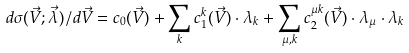<formula> <loc_0><loc_0><loc_500><loc_500>d \sigma ( \vec { V } ; \vec { \lambda } ) / d \vec { V } = c _ { 0 } ( \vec { V } ) + \sum _ { k } c ^ { k } _ { 1 } ( \vec { V } ) \cdot \lambda _ { k } + \sum _ { \mu , k } c _ { 2 } ^ { \mu k } ( \vec { V } ) \cdot \lambda _ { \mu } \cdot \lambda _ { k }</formula> 